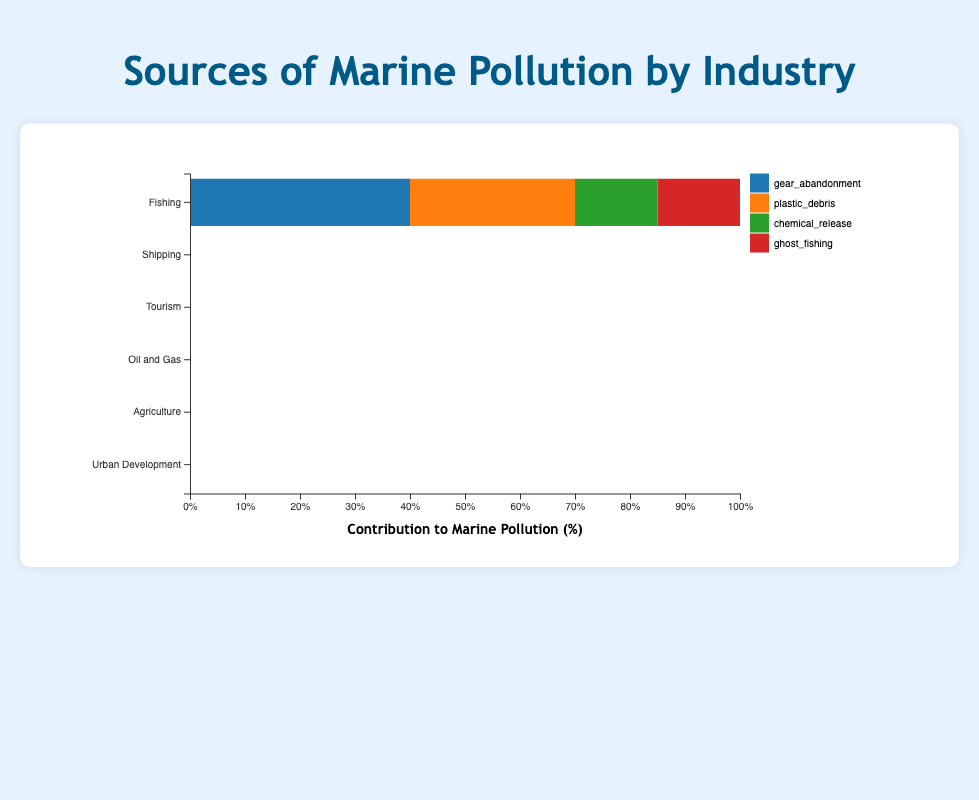Which industry has the highest contribution to plastic waste? To answer this, we look at the relative contributions of plastic waste across the industries. Tourism contributes 50% to plastic waste.
Answer: Tourism What are the three major sources of pollution by percentage for the Fishing industry? For this, observe Fishing's bar segments: gear abandonment (40%), plastic debris (30%), and chemical release/ghost fishing (both 15%). The top three are gear abandonment, plastic debris, and chemical release/ghost fishing.
Answer: Gear abandonment (40%), plastic debris (30%), chemical release or ghost fishing (15%) Compare the contributions of oil spills from the Shipping and Oil and Gas industries. Which is greater, and by how much? Shipping contributes 45% to oil spills, and Oil and Gas contributes 30%. Subtract 30 from 45 to find the difference.
Answer: Shipping by 15% What is the similarity between pollution sources in Tourism and Urban Development industries? Both industries show pollution segmentation. Plastic waste in Tourism (50%) and stormwater runoff in Urban Development (60%) are major contributors. Both also show secondary contributions (sewage discharge 20%, construction debris 20%). Plastic waste and secondary types' exact percentages are not the same, but they show a similar pattern.
Answer: Both have one dominant and several mid-range contributors If the total contribution of chemical pollutants (chemical release in Fishing and chemical runoff in Oil and Gas) is considered, which is more significant, Fishing or Oil and Gas? Fishing has 15% chemical release, and Oil and Gas has 10% chemical runoff. By comparing these values directly, Fishing is more significant.
Answer: Fishing 